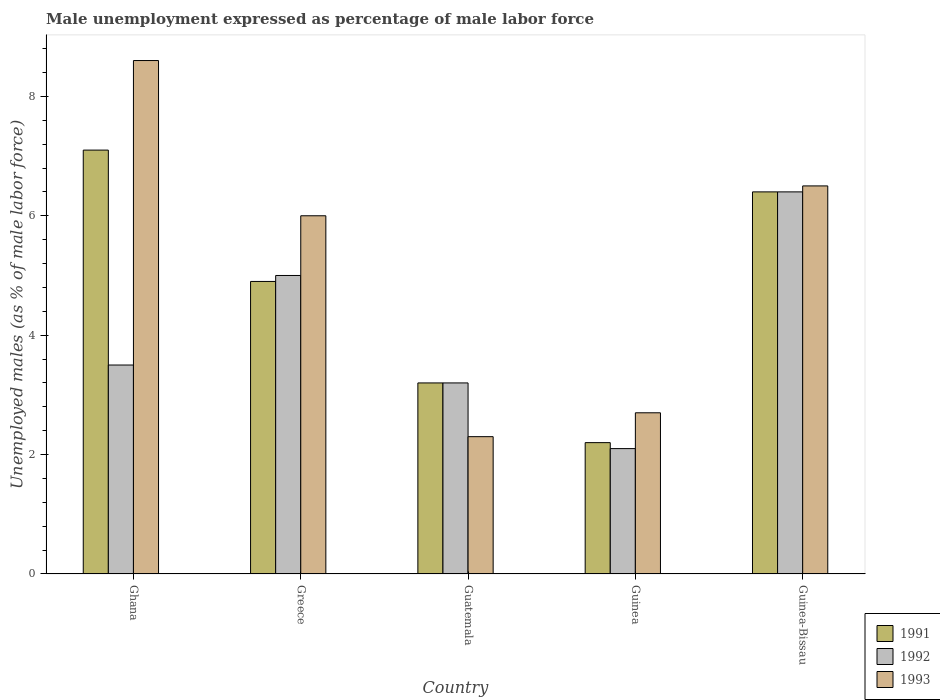Are the number of bars on each tick of the X-axis equal?
Your answer should be very brief. Yes. How many bars are there on the 1st tick from the left?
Your response must be concise. 3. What is the label of the 5th group of bars from the left?
Make the answer very short. Guinea-Bissau. What is the unemployment in males in in 1991 in Guinea-Bissau?
Your response must be concise. 6.4. Across all countries, what is the maximum unemployment in males in in 1992?
Offer a terse response. 6.4. Across all countries, what is the minimum unemployment in males in in 1992?
Make the answer very short. 2.1. In which country was the unemployment in males in in 1993 maximum?
Provide a short and direct response. Ghana. In which country was the unemployment in males in in 1991 minimum?
Make the answer very short. Guinea. What is the total unemployment in males in in 1991 in the graph?
Make the answer very short. 23.8. What is the difference between the unemployment in males in in 1992 in Greece and that in Guatemala?
Your answer should be compact. 1.8. What is the difference between the unemployment in males in in 1992 in Guatemala and the unemployment in males in in 1993 in Ghana?
Your answer should be compact. -5.4. What is the average unemployment in males in in 1992 per country?
Your answer should be compact. 4.04. What is the difference between the unemployment in males in of/in 1992 and unemployment in males in of/in 1993 in Guatemala?
Offer a terse response. 0.9. What is the ratio of the unemployment in males in in 1992 in Ghana to that in Guatemala?
Ensure brevity in your answer.  1.09. Is the difference between the unemployment in males in in 1992 in Greece and Guinea-Bissau greater than the difference between the unemployment in males in in 1993 in Greece and Guinea-Bissau?
Keep it short and to the point. No. What is the difference between the highest and the second highest unemployment in males in in 1993?
Keep it short and to the point. 2.1. What is the difference between the highest and the lowest unemployment in males in in 1991?
Your answer should be compact. 4.9. Is the sum of the unemployment in males in in 1991 in Ghana and Guinea greater than the maximum unemployment in males in in 1992 across all countries?
Offer a very short reply. Yes. What does the 2nd bar from the right in Guatemala represents?
Keep it short and to the point. 1992. How many countries are there in the graph?
Keep it short and to the point. 5. What is the difference between two consecutive major ticks on the Y-axis?
Make the answer very short. 2. Does the graph contain any zero values?
Ensure brevity in your answer.  No. Does the graph contain grids?
Give a very brief answer. No. Where does the legend appear in the graph?
Offer a very short reply. Bottom right. How many legend labels are there?
Provide a succinct answer. 3. What is the title of the graph?
Make the answer very short. Male unemployment expressed as percentage of male labor force. Does "2000" appear as one of the legend labels in the graph?
Give a very brief answer. No. What is the label or title of the X-axis?
Keep it short and to the point. Country. What is the label or title of the Y-axis?
Keep it short and to the point. Unemployed males (as % of male labor force). What is the Unemployed males (as % of male labor force) in 1991 in Ghana?
Your response must be concise. 7.1. What is the Unemployed males (as % of male labor force) of 1993 in Ghana?
Offer a very short reply. 8.6. What is the Unemployed males (as % of male labor force) of 1991 in Greece?
Keep it short and to the point. 4.9. What is the Unemployed males (as % of male labor force) in 1991 in Guatemala?
Provide a short and direct response. 3.2. What is the Unemployed males (as % of male labor force) in 1992 in Guatemala?
Keep it short and to the point. 3.2. What is the Unemployed males (as % of male labor force) in 1993 in Guatemala?
Your answer should be compact. 2.3. What is the Unemployed males (as % of male labor force) of 1991 in Guinea?
Your response must be concise. 2.2. What is the Unemployed males (as % of male labor force) in 1992 in Guinea?
Make the answer very short. 2.1. What is the Unemployed males (as % of male labor force) of 1993 in Guinea?
Offer a terse response. 2.7. What is the Unemployed males (as % of male labor force) of 1991 in Guinea-Bissau?
Ensure brevity in your answer.  6.4. What is the Unemployed males (as % of male labor force) of 1992 in Guinea-Bissau?
Your answer should be compact. 6.4. Across all countries, what is the maximum Unemployed males (as % of male labor force) of 1991?
Your answer should be very brief. 7.1. Across all countries, what is the maximum Unemployed males (as % of male labor force) of 1992?
Provide a succinct answer. 6.4. Across all countries, what is the maximum Unemployed males (as % of male labor force) of 1993?
Provide a succinct answer. 8.6. Across all countries, what is the minimum Unemployed males (as % of male labor force) of 1991?
Give a very brief answer. 2.2. Across all countries, what is the minimum Unemployed males (as % of male labor force) in 1992?
Give a very brief answer. 2.1. Across all countries, what is the minimum Unemployed males (as % of male labor force) in 1993?
Offer a very short reply. 2.3. What is the total Unemployed males (as % of male labor force) in 1991 in the graph?
Your response must be concise. 23.8. What is the total Unemployed males (as % of male labor force) in 1992 in the graph?
Provide a succinct answer. 20.2. What is the total Unemployed males (as % of male labor force) in 1993 in the graph?
Your answer should be very brief. 26.1. What is the difference between the Unemployed males (as % of male labor force) of 1991 in Ghana and that in Greece?
Offer a terse response. 2.2. What is the difference between the Unemployed males (as % of male labor force) of 1993 in Ghana and that in Greece?
Provide a succinct answer. 2.6. What is the difference between the Unemployed males (as % of male labor force) in 1992 in Ghana and that in Guatemala?
Make the answer very short. 0.3. What is the difference between the Unemployed males (as % of male labor force) of 1991 in Ghana and that in Guinea?
Offer a very short reply. 4.9. What is the difference between the Unemployed males (as % of male labor force) of 1992 in Ghana and that in Guinea?
Give a very brief answer. 1.4. What is the difference between the Unemployed males (as % of male labor force) of 1991 in Ghana and that in Guinea-Bissau?
Give a very brief answer. 0.7. What is the difference between the Unemployed males (as % of male labor force) of 1993 in Ghana and that in Guinea-Bissau?
Your answer should be very brief. 2.1. What is the difference between the Unemployed males (as % of male labor force) in 1991 in Greece and that in Guatemala?
Offer a terse response. 1.7. What is the difference between the Unemployed males (as % of male labor force) in 1992 in Greece and that in Guinea?
Provide a succinct answer. 2.9. What is the difference between the Unemployed males (as % of male labor force) in 1993 in Greece and that in Guinea?
Your answer should be very brief. 3.3. What is the difference between the Unemployed males (as % of male labor force) of 1992 in Greece and that in Guinea-Bissau?
Your answer should be very brief. -1.4. What is the difference between the Unemployed males (as % of male labor force) in 1993 in Greece and that in Guinea-Bissau?
Keep it short and to the point. -0.5. What is the difference between the Unemployed males (as % of male labor force) in 1991 in Guatemala and that in Guinea?
Your answer should be very brief. 1. What is the difference between the Unemployed males (as % of male labor force) in 1993 in Guatemala and that in Guinea?
Provide a succinct answer. -0.4. What is the difference between the Unemployed males (as % of male labor force) in 1993 in Guatemala and that in Guinea-Bissau?
Offer a terse response. -4.2. What is the difference between the Unemployed males (as % of male labor force) of 1991 in Guinea and that in Guinea-Bissau?
Ensure brevity in your answer.  -4.2. What is the difference between the Unemployed males (as % of male labor force) of 1992 in Ghana and the Unemployed males (as % of male labor force) of 1993 in Greece?
Provide a succinct answer. -2.5. What is the difference between the Unemployed males (as % of male labor force) in 1991 in Ghana and the Unemployed males (as % of male labor force) in 1992 in Guatemala?
Provide a succinct answer. 3.9. What is the difference between the Unemployed males (as % of male labor force) of 1991 in Ghana and the Unemployed males (as % of male labor force) of 1992 in Guinea?
Your answer should be compact. 5. What is the difference between the Unemployed males (as % of male labor force) of 1991 in Ghana and the Unemployed males (as % of male labor force) of 1993 in Guinea?
Offer a very short reply. 4.4. What is the difference between the Unemployed males (as % of male labor force) of 1991 in Greece and the Unemployed males (as % of male labor force) of 1993 in Guatemala?
Make the answer very short. 2.6. What is the difference between the Unemployed males (as % of male labor force) of 1991 in Greece and the Unemployed males (as % of male labor force) of 1992 in Guinea?
Keep it short and to the point. 2.8. What is the difference between the Unemployed males (as % of male labor force) of 1991 in Greece and the Unemployed males (as % of male labor force) of 1993 in Guinea?
Keep it short and to the point. 2.2. What is the difference between the Unemployed males (as % of male labor force) of 1992 in Greece and the Unemployed males (as % of male labor force) of 1993 in Guinea?
Ensure brevity in your answer.  2.3. What is the difference between the Unemployed males (as % of male labor force) in 1992 in Greece and the Unemployed males (as % of male labor force) in 1993 in Guinea-Bissau?
Provide a succinct answer. -1.5. What is the difference between the Unemployed males (as % of male labor force) of 1991 in Guatemala and the Unemployed males (as % of male labor force) of 1993 in Guinea?
Ensure brevity in your answer.  0.5. What is the difference between the Unemployed males (as % of male labor force) of 1992 in Guatemala and the Unemployed males (as % of male labor force) of 1993 in Guinea?
Give a very brief answer. 0.5. What is the difference between the Unemployed males (as % of male labor force) in 1991 in Guatemala and the Unemployed males (as % of male labor force) in 1993 in Guinea-Bissau?
Offer a terse response. -3.3. What is the difference between the Unemployed males (as % of male labor force) in 1991 in Guinea and the Unemployed males (as % of male labor force) in 1992 in Guinea-Bissau?
Your answer should be compact. -4.2. What is the difference between the Unemployed males (as % of male labor force) of 1991 in Guinea and the Unemployed males (as % of male labor force) of 1993 in Guinea-Bissau?
Your answer should be compact. -4.3. What is the difference between the Unemployed males (as % of male labor force) in 1992 in Guinea and the Unemployed males (as % of male labor force) in 1993 in Guinea-Bissau?
Make the answer very short. -4.4. What is the average Unemployed males (as % of male labor force) in 1991 per country?
Offer a very short reply. 4.76. What is the average Unemployed males (as % of male labor force) in 1992 per country?
Your answer should be very brief. 4.04. What is the average Unemployed males (as % of male labor force) in 1993 per country?
Provide a succinct answer. 5.22. What is the difference between the Unemployed males (as % of male labor force) in 1991 and Unemployed males (as % of male labor force) in 1992 in Ghana?
Make the answer very short. 3.6. What is the difference between the Unemployed males (as % of male labor force) of 1991 and Unemployed males (as % of male labor force) of 1993 in Ghana?
Your answer should be compact. -1.5. What is the difference between the Unemployed males (as % of male labor force) in 1991 and Unemployed males (as % of male labor force) in 1992 in Greece?
Your response must be concise. -0.1. What is the difference between the Unemployed males (as % of male labor force) in 1991 and Unemployed males (as % of male labor force) in 1993 in Greece?
Your answer should be very brief. -1.1. What is the difference between the Unemployed males (as % of male labor force) in 1992 and Unemployed males (as % of male labor force) in 1993 in Greece?
Your answer should be compact. -1. What is the difference between the Unemployed males (as % of male labor force) in 1991 and Unemployed males (as % of male labor force) in 1992 in Guatemala?
Offer a terse response. 0. What is the difference between the Unemployed males (as % of male labor force) of 1991 and Unemployed males (as % of male labor force) of 1992 in Guinea?
Your response must be concise. 0.1. What is the difference between the Unemployed males (as % of male labor force) in 1991 and Unemployed males (as % of male labor force) in 1993 in Guinea-Bissau?
Offer a very short reply. -0.1. What is the difference between the Unemployed males (as % of male labor force) in 1992 and Unemployed males (as % of male labor force) in 1993 in Guinea-Bissau?
Your response must be concise. -0.1. What is the ratio of the Unemployed males (as % of male labor force) of 1991 in Ghana to that in Greece?
Provide a succinct answer. 1.45. What is the ratio of the Unemployed males (as % of male labor force) of 1993 in Ghana to that in Greece?
Offer a very short reply. 1.43. What is the ratio of the Unemployed males (as % of male labor force) of 1991 in Ghana to that in Guatemala?
Give a very brief answer. 2.22. What is the ratio of the Unemployed males (as % of male labor force) of 1992 in Ghana to that in Guatemala?
Make the answer very short. 1.09. What is the ratio of the Unemployed males (as % of male labor force) of 1993 in Ghana to that in Guatemala?
Your answer should be very brief. 3.74. What is the ratio of the Unemployed males (as % of male labor force) in 1991 in Ghana to that in Guinea?
Provide a succinct answer. 3.23. What is the ratio of the Unemployed males (as % of male labor force) in 1993 in Ghana to that in Guinea?
Provide a succinct answer. 3.19. What is the ratio of the Unemployed males (as % of male labor force) of 1991 in Ghana to that in Guinea-Bissau?
Offer a terse response. 1.11. What is the ratio of the Unemployed males (as % of male labor force) of 1992 in Ghana to that in Guinea-Bissau?
Provide a succinct answer. 0.55. What is the ratio of the Unemployed males (as % of male labor force) of 1993 in Ghana to that in Guinea-Bissau?
Ensure brevity in your answer.  1.32. What is the ratio of the Unemployed males (as % of male labor force) in 1991 in Greece to that in Guatemala?
Your response must be concise. 1.53. What is the ratio of the Unemployed males (as % of male labor force) in 1992 in Greece to that in Guatemala?
Offer a very short reply. 1.56. What is the ratio of the Unemployed males (as % of male labor force) in 1993 in Greece to that in Guatemala?
Your answer should be very brief. 2.61. What is the ratio of the Unemployed males (as % of male labor force) in 1991 in Greece to that in Guinea?
Provide a short and direct response. 2.23. What is the ratio of the Unemployed males (as % of male labor force) of 1992 in Greece to that in Guinea?
Make the answer very short. 2.38. What is the ratio of the Unemployed males (as % of male labor force) in 1993 in Greece to that in Guinea?
Ensure brevity in your answer.  2.22. What is the ratio of the Unemployed males (as % of male labor force) of 1991 in Greece to that in Guinea-Bissau?
Keep it short and to the point. 0.77. What is the ratio of the Unemployed males (as % of male labor force) in 1992 in Greece to that in Guinea-Bissau?
Offer a very short reply. 0.78. What is the ratio of the Unemployed males (as % of male labor force) in 1991 in Guatemala to that in Guinea?
Give a very brief answer. 1.45. What is the ratio of the Unemployed males (as % of male labor force) in 1992 in Guatemala to that in Guinea?
Offer a terse response. 1.52. What is the ratio of the Unemployed males (as % of male labor force) of 1993 in Guatemala to that in Guinea?
Make the answer very short. 0.85. What is the ratio of the Unemployed males (as % of male labor force) of 1991 in Guatemala to that in Guinea-Bissau?
Make the answer very short. 0.5. What is the ratio of the Unemployed males (as % of male labor force) in 1993 in Guatemala to that in Guinea-Bissau?
Ensure brevity in your answer.  0.35. What is the ratio of the Unemployed males (as % of male labor force) of 1991 in Guinea to that in Guinea-Bissau?
Your response must be concise. 0.34. What is the ratio of the Unemployed males (as % of male labor force) of 1992 in Guinea to that in Guinea-Bissau?
Your response must be concise. 0.33. What is the ratio of the Unemployed males (as % of male labor force) of 1993 in Guinea to that in Guinea-Bissau?
Provide a succinct answer. 0.42. What is the difference between the highest and the second highest Unemployed males (as % of male labor force) in 1991?
Give a very brief answer. 0.7. What is the difference between the highest and the second highest Unemployed males (as % of male labor force) in 1992?
Ensure brevity in your answer.  1.4. What is the difference between the highest and the second highest Unemployed males (as % of male labor force) in 1993?
Your response must be concise. 2.1. What is the difference between the highest and the lowest Unemployed males (as % of male labor force) in 1991?
Your answer should be compact. 4.9. What is the difference between the highest and the lowest Unemployed males (as % of male labor force) in 1993?
Make the answer very short. 6.3. 